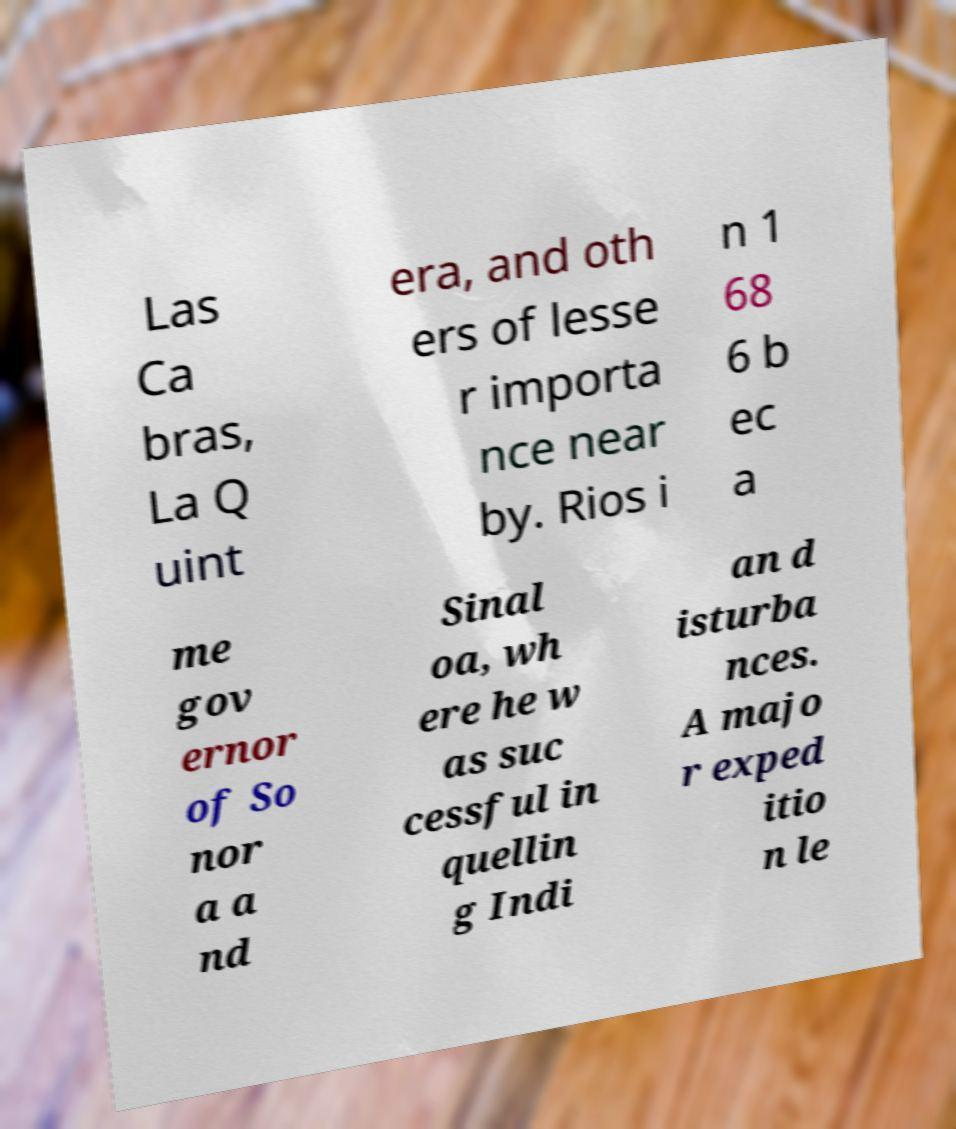Can you accurately transcribe the text from the provided image for me? Las Ca bras, La Q uint era, and oth ers of lesse r importa nce near by. Rios i n 1 68 6 b ec a me gov ernor of So nor a a nd Sinal oa, wh ere he w as suc cessful in quellin g Indi an d isturba nces. A majo r exped itio n le 